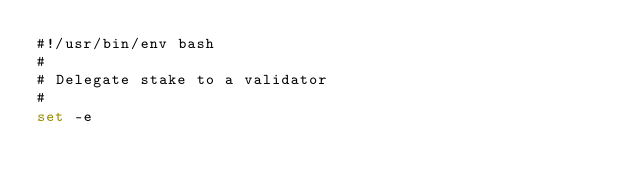<code> <loc_0><loc_0><loc_500><loc_500><_Bash_>#!/usr/bin/env bash
#
# Delegate stake to a validator
#
set -e
</code> 